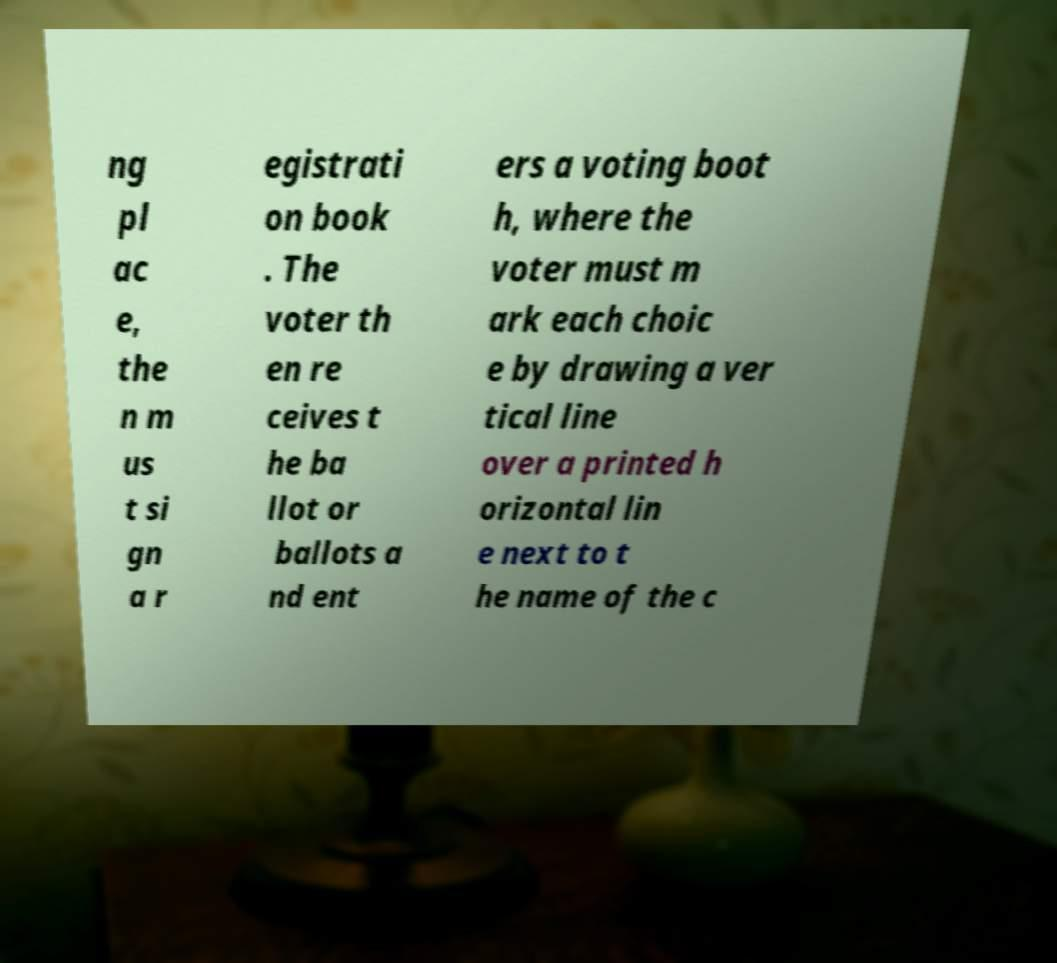Could you extract and type out the text from this image? ng pl ac e, the n m us t si gn a r egistrati on book . The voter th en re ceives t he ba llot or ballots a nd ent ers a voting boot h, where the voter must m ark each choic e by drawing a ver tical line over a printed h orizontal lin e next to t he name of the c 